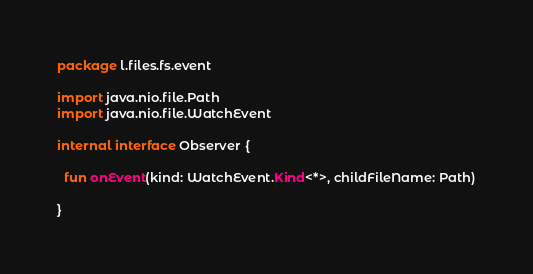Convert code to text. <code><loc_0><loc_0><loc_500><loc_500><_Kotlin_>package l.files.fs.event

import java.nio.file.Path
import java.nio.file.WatchEvent

internal interface Observer {

  fun onEvent(kind: WatchEvent.Kind<*>, childFileName: Path)

}
</code> 